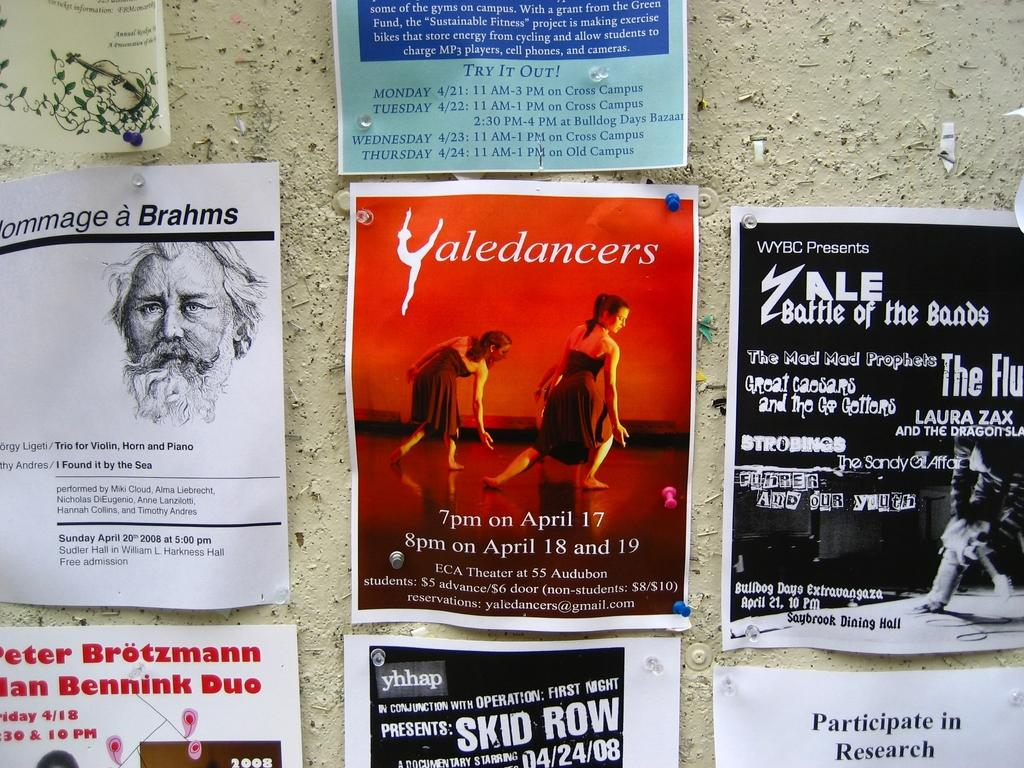<image>
Give a short and clear explanation of the subsequent image. A board with notices on it advertises a Skid Row concert. 